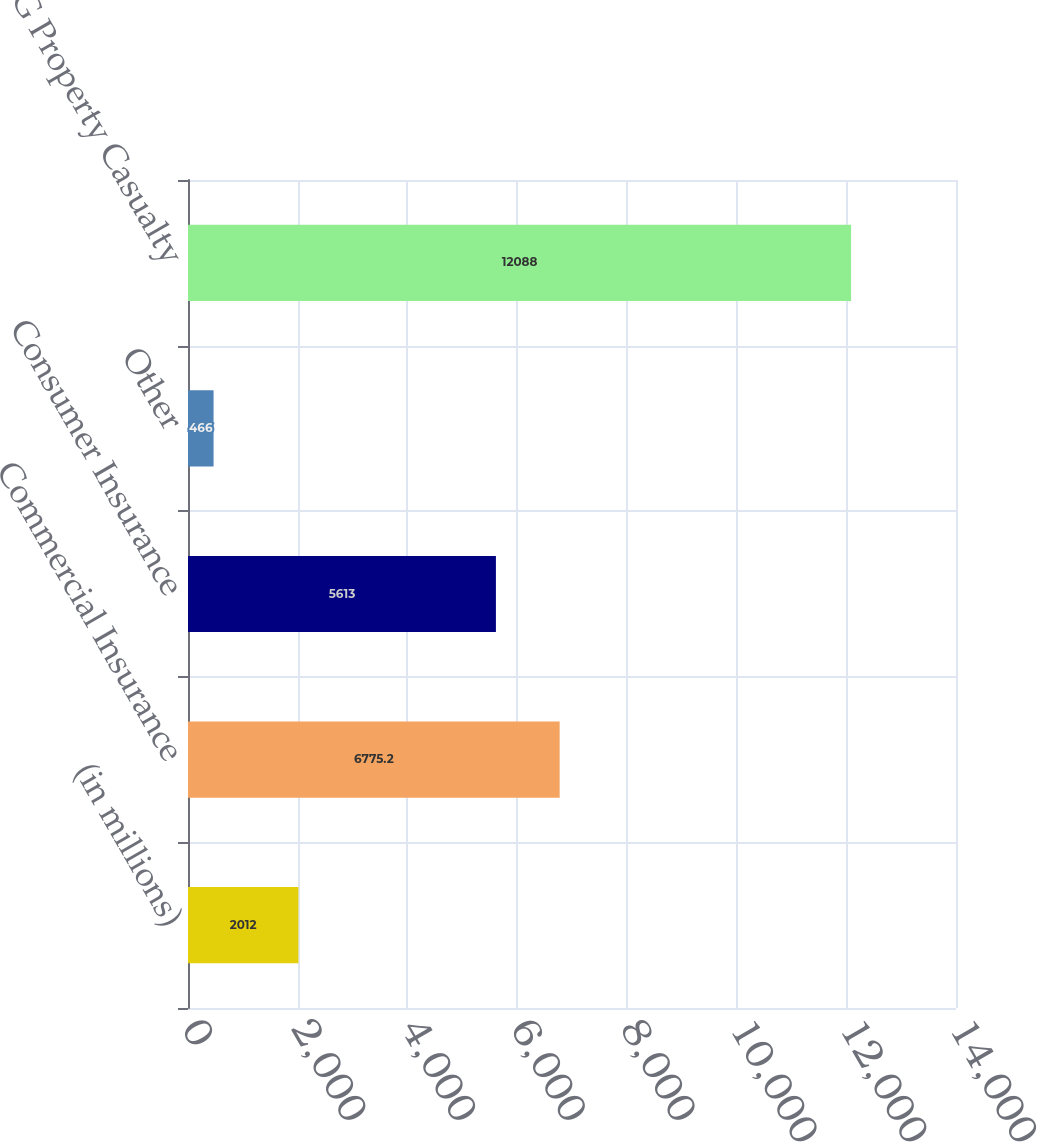Convert chart to OTSL. <chart><loc_0><loc_0><loc_500><loc_500><bar_chart><fcel>(in millions)<fcel>Commercial Insurance<fcel>Consumer Insurance<fcel>Other<fcel>Total AIG Property Casualty<nl><fcel>2012<fcel>6775.2<fcel>5613<fcel>466<fcel>12088<nl></chart> 